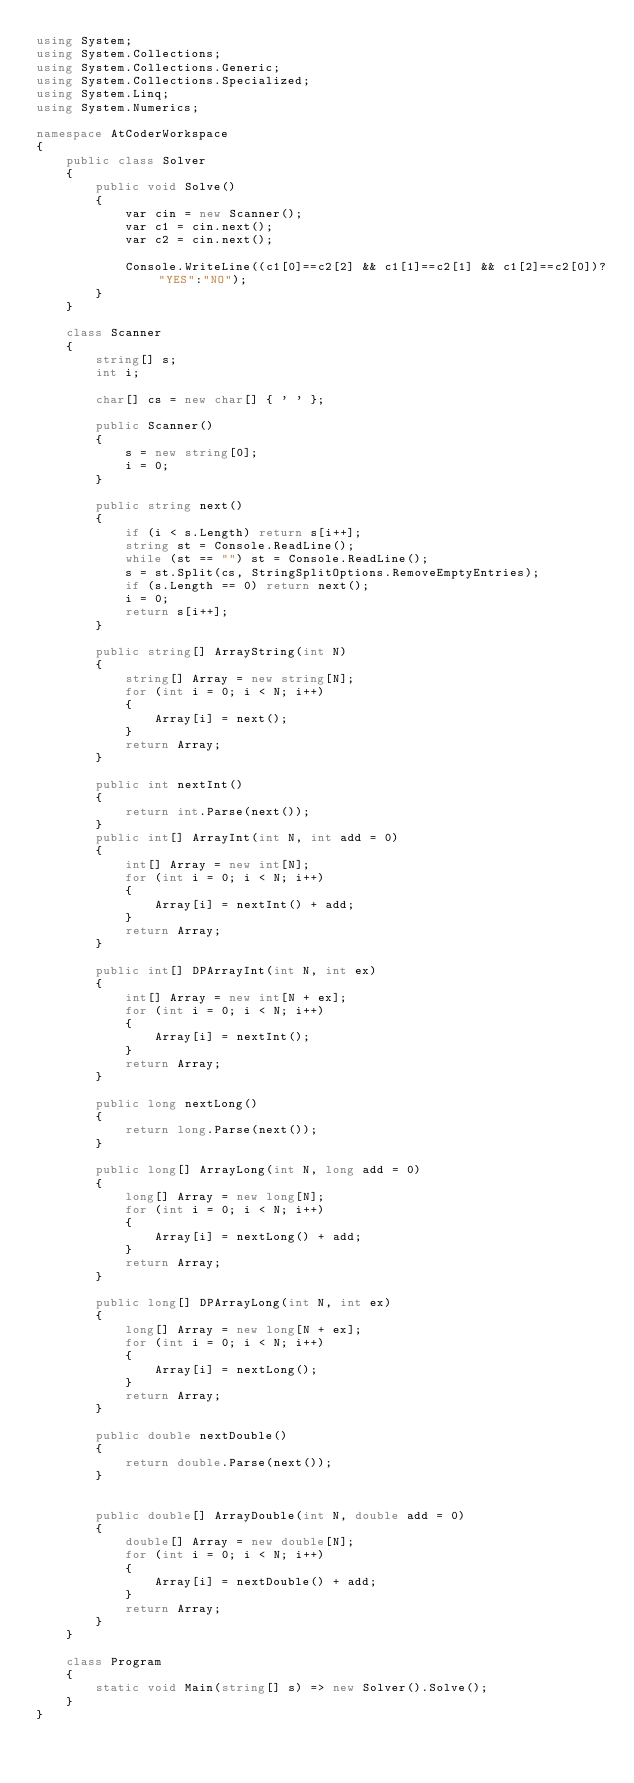<code> <loc_0><loc_0><loc_500><loc_500><_C#_>using System;
using System.Collections;
using System.Collections.Generic;
using System.Collections.Specialized;
using System.Linq;
using System.Numerics;

namespace AtCoderWorkspace
{
    public class Solver
    {
        public void Solve()
        {
            var cin = new Scanner();
            var c1 = cin.next();
            var c2 = cin.next();

            Console.WriteLine((c1[0]==c2[2] && c1[1]==c2[1] && c1[2]==c2[0])?"YES":"NO");
        }
    }

    class Scanner
    {
        string[] s;
        int i;

        char[] cs = new char[] { ' ' };

        public Scanner()
        {
            s = new string[0];
            i = 0;
        }

        public string next()
        {
            if (i < s.Length) return s[i++];
            string st = Console.ReadLine();
            while (st == "") st = Console.ReadLine();
            s = st.Split(cs, StringSplitOptions.RemoveEmptyEntries);
            if (s.Length == 0) return next();
            i = 0;
            return s[i++];
        }

        public string[] ArrayString(int N)
        {
            string[] Array = new string[N];
            for (int i = 0; i < N; i++)
            {
                Array[i] = next();
            }
            return Array;
        }

        public int nextInt()
        {
            return int.Parse(next());
        }
        public int[] ArrayInt(int N, int add = 0)
        {
            int[] Array = new int[N];
            for (int i = 0; i < N; i++)
            {
                Array[i] = nextInt() + add;
            }
            return Array;
        }

        public int[] DPArrayInt(int N, int ex)
        {
            int[] Array = new int[N + ex];
            for (int i = 0; i < N; i++)
            {
                Array[i] = nextInt();
            }
            return Array;
        }

        public long nextLong()
        {
            return long.Parse(next());
        }

        public long[] ArrayLong(int N, long add = 0)
        {
            long[] Array = new long[N];
            for (int i = 0; i < N; i++)
            {
                Array[i] = nextLong() + add;
            }
            return Array;
        }

        public long[] DPArrayLong(int N, int ex)
        {
            long[] Array = new long[N + ex];
            for (int i = 0; i < N; i++)
            {
                Array[i] = nextLong();
            }
            return Array;
        }

        public double nextDouble()
        {
            return double.Parse(next());
        }


        public double[] ArrayDouble(int N, double add = 0)
        {
            double[] Array = new double[N];
            for (int i = 0; i < N; i++)
            {
                Array[i] = nextDouble() + add;
            }
            return Array;
        }
    }

    class Program
    {
        static void Main(string[] s) => new Solver().Solve();
    }
}
</code> 